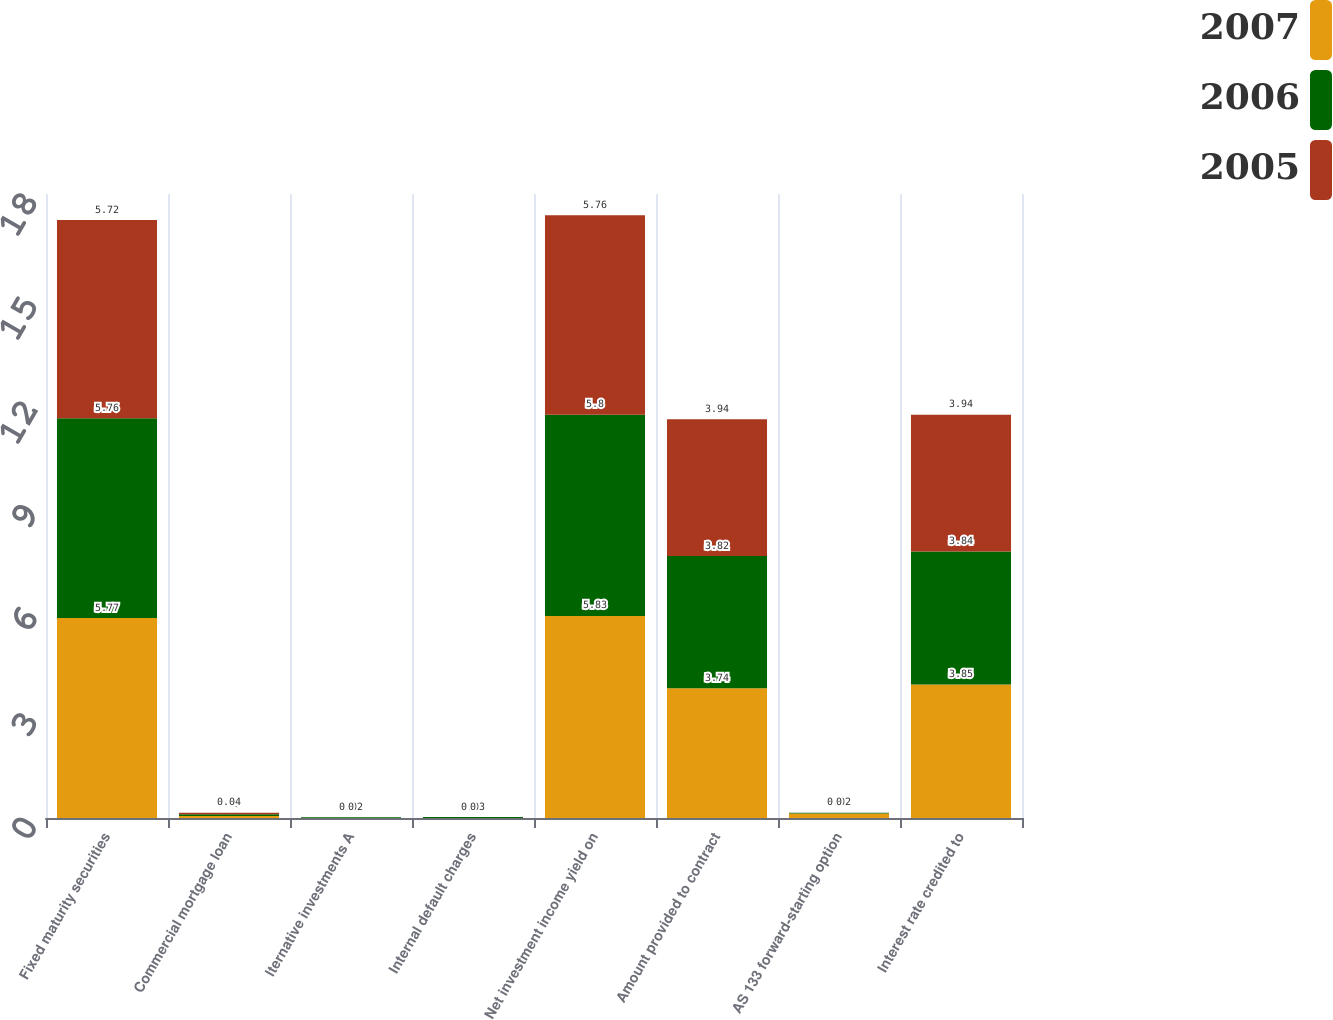<chart> <loc_0><loc_0><loc_500><loc_500><stacked_bar_chart><ecel><fcel>Fixed maturity securities<fcel>Commercial mortgage loan<fcel>lternative investments A<fcel>Internal default charges<fcel>Net investment income yield on<fcel>Amount provided to contract<fcel>AS 133 forward-starting option<fcel>Interest rate credited to<nl><fcel>2007<fcel>5.77<fcel>0.06<fcel>0<fcel>0<fcel>5.83<fcel>3.74<fcel>0.13<fcel>3.85<nl><fcel>2006<fcel>5.76<fcel>0.05<fcel>0.02<fcel>0.03<fcel>5.8<fcel>3.82<fcel>0.02<fcel>3.84<nl><fcel>2005<fcel>5.72<fcel>0.04<fcel>0<fcel>0<fcel>5.76<fcel>3.94<fcel>0<fcel>3.94<nl></chart> 